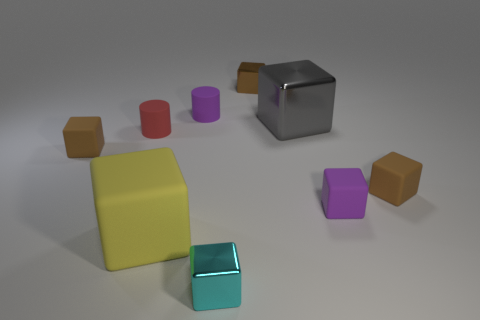Subtract all green spheres. How many brown blocks are left? 3 Subtract all purple cubes. How many cubes are left? 6 Subtract all large gray shiny blocks. How many blocks are left? 6 Subtract all gray cubes. Subtract all brown cylinders. How many cubes are left? 6 Add 1 big gray shiny things. How many objects exist? 10 Subtract all cubes. How many objects are left? 2 Add 6 small metallic things. How many small metallic things are left? 8 Add 1 tiny yellow metal cubes. How many tiny yellow metal cubes exist? 1 Subtract 0 blue balls. How many objects are left? 9 Subtract all green rubber balls. Subtract all big shiny things. How many objects are left? 8 